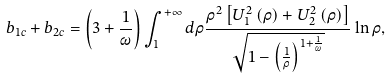<formula> <loc_0><loc_0><loc_500><loc_500>b _ { 1 c } + b _ { 2 c } = \left ( 3 + \frac { 1 } { \omega } \right ) \int _ { 1 } ^ { + \infty } d \rho \frac { \rho ^ { 2 } \left [ U _ { 1 } ^ { 2 } \left ( \rho \right ) + U _ { 2 } ^ { 2 } \left ( \rho \right ) \right ] } { \sqrt { 1 - \left ( \frac { 1 } { \rho } \right ) ^ { 1 + \frac { 1 } { \omega } } } } \ln \rho ,</formula> 